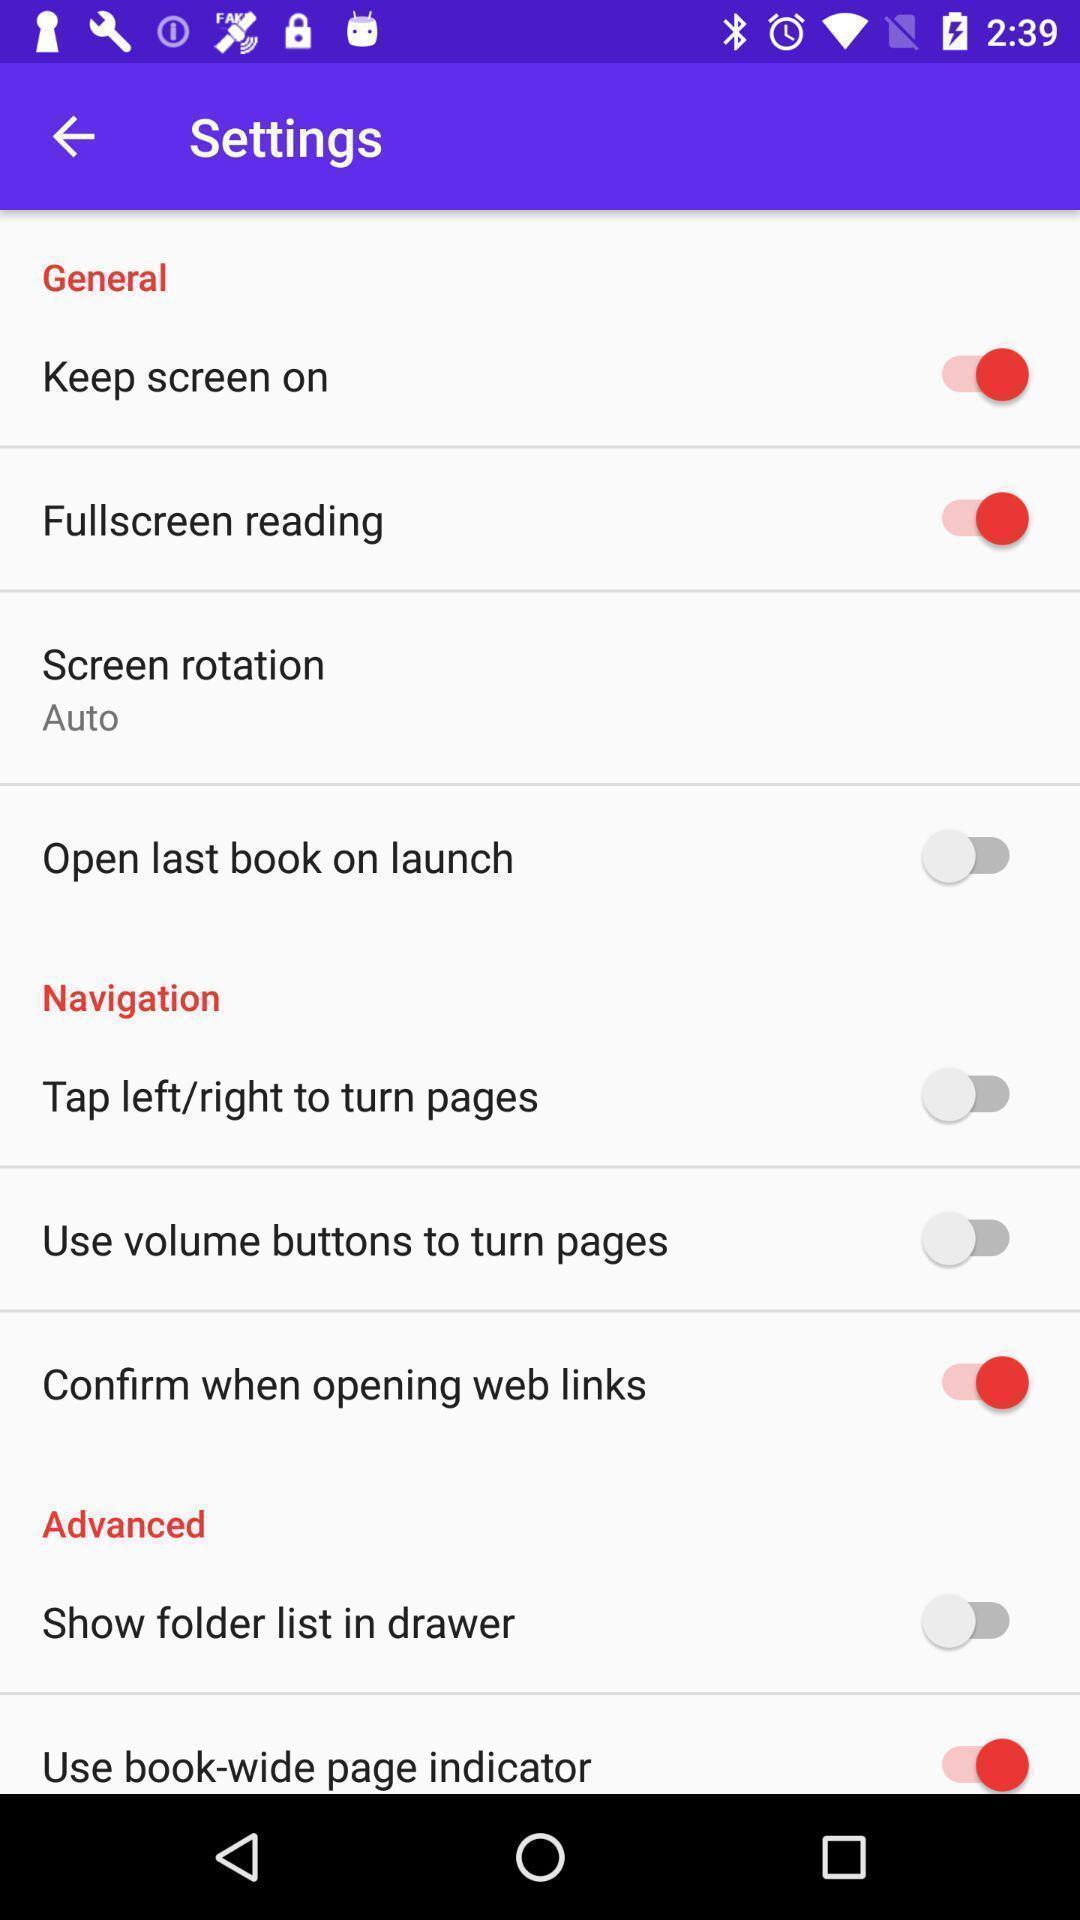What can you discern from this picture? Screen displaying the various options in settings tab. 